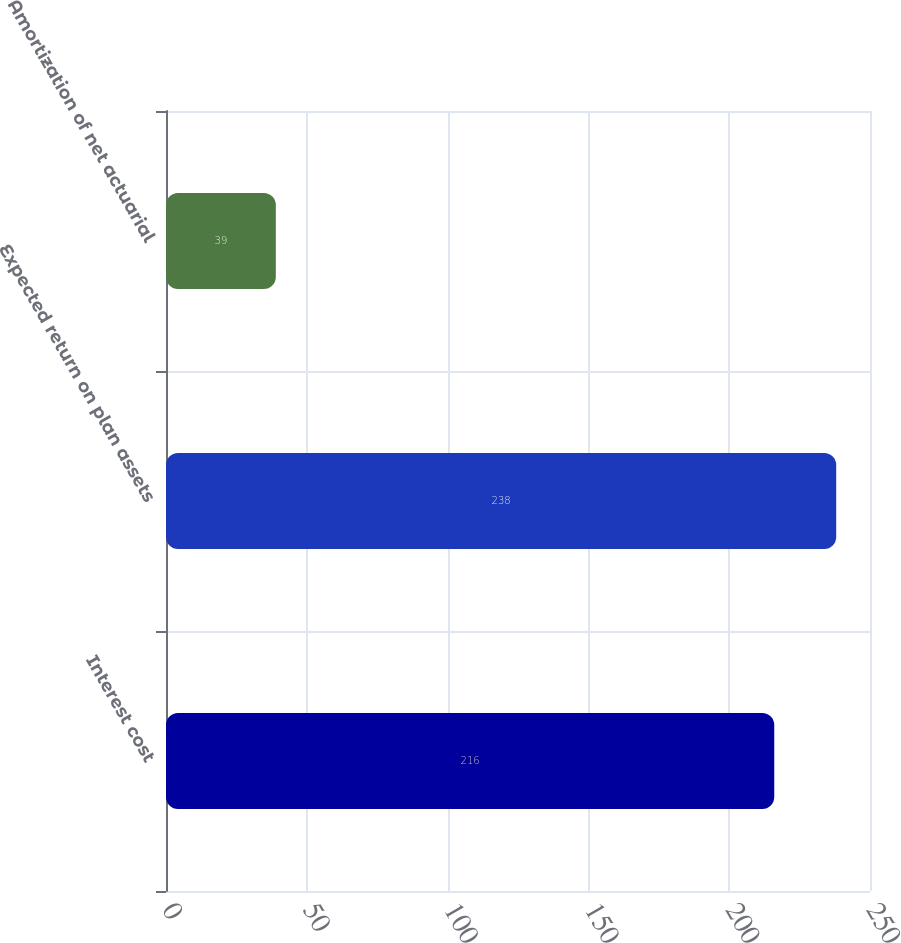Convert chart. <chart><loc_0><loc_0><loc_500><loc_500><bar_chart><fcel>Interest cost<fcel>Expected return on plan assets<fcel>Amortization of net actuarial<nl><fcel>216<fcel>238<fcel>39<nl></chart> 